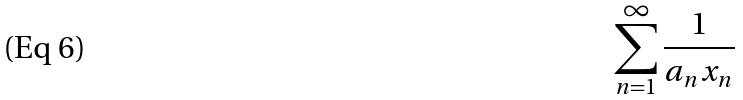<formula> <loc_0><loc_0><loc_500><loc_500>\sum _ { n = 1 } ^ { \infty } \frac { 1 } { a _ { n } x _ { n } }</formula> 